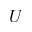<formula> <loc_0><loc_0><loc_500><loc_500>U</formula> 